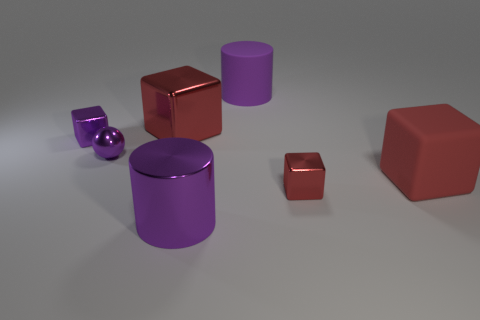How many red blocks must be subtracted to get 1 red blocks? 2 Subtract all red cubes. How many cubes are left? 1 Subtract all balls. How many objects are left? 6 Subtract 1 spheres. How many spheres are left? 0 Subtract all green spheres. Subtract all purple cubes. How many spheres are left? 1 Subtract all purple cylinders. How many brown blocks are left? 0 Subtract all tiny red cylinders. Subtract all small red shiny objects. How many objects are left? 6 Add 6 large things. How many large things are left? 10 Add 5 large rubber cylinders. How many large rubber cylinders exist? 6 Add 3 red metal cubes. How many objects exist? 10 